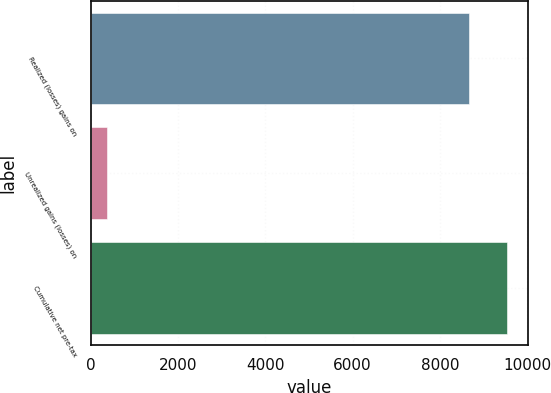Convert chart to OTSL. <chart><loc_0><loc_0><loc_500><loc_500><bar_chart><fcel>Realized (losses) gains on<fcel>Unrealized gains (losses) on<fcel>Cumulative net pre-tax<nl><fcel>8666<fcel>361<fcel>9532.6<nl></chart> 